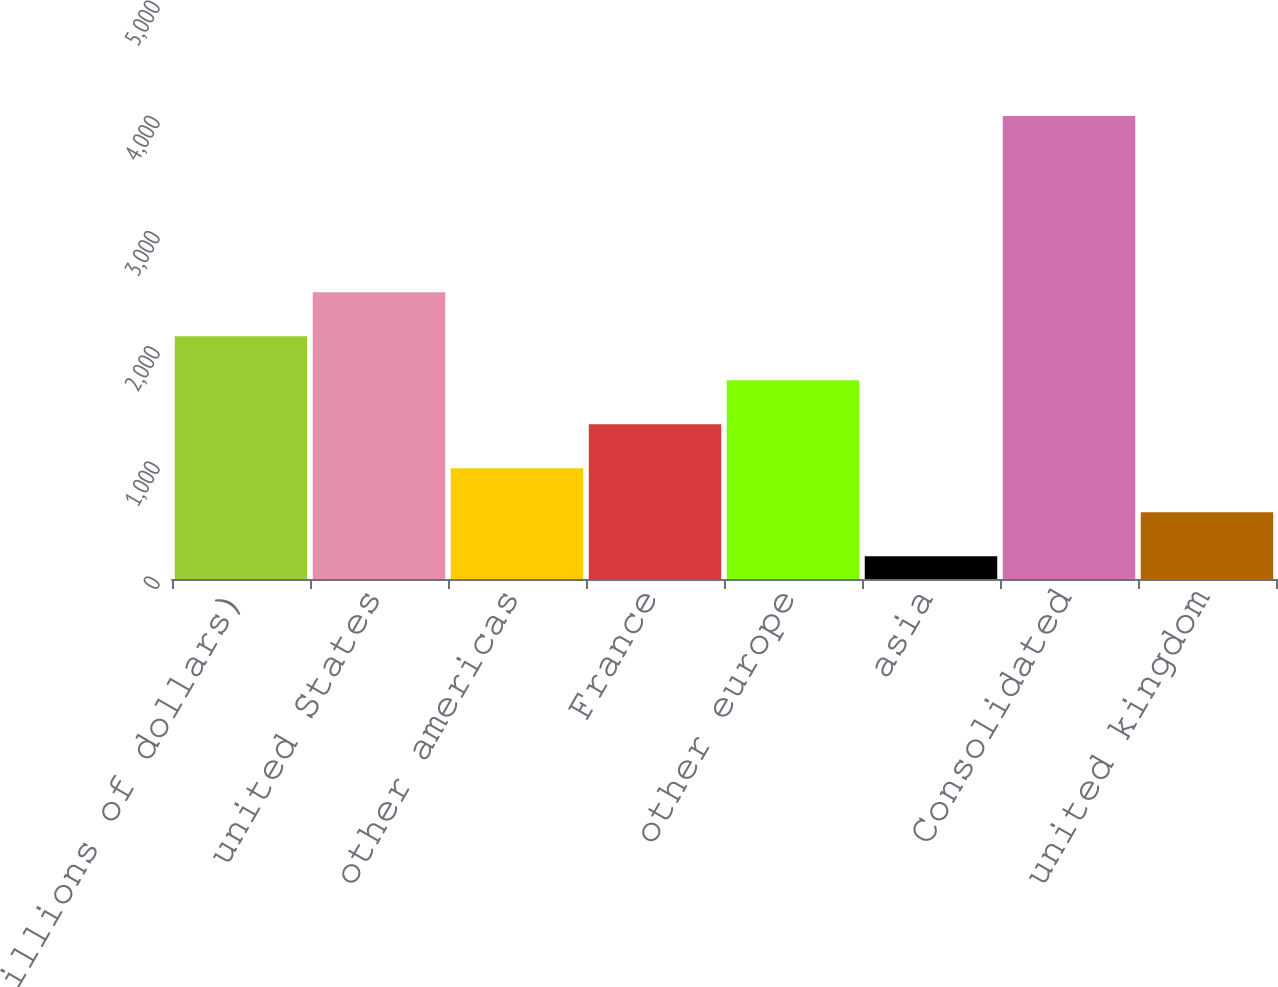Convert chart to OTSL. <chart><loc_0><loc_0><loc_500><loc_500><bar_chart><fcel>(millions of dollars)<fcel>united States<fcel>other americas<fcel>France<fcel>other europe<fcel>asia<fcel>Consolidated<fcel>united kingdom<nl><fcel>2107.95<fcel>2490.08<fcel>961.56<fcel>1343.69<fcel>1725.82<fcel>197.3<fcel>4018.6<fcel>579.43<nl></chart> 